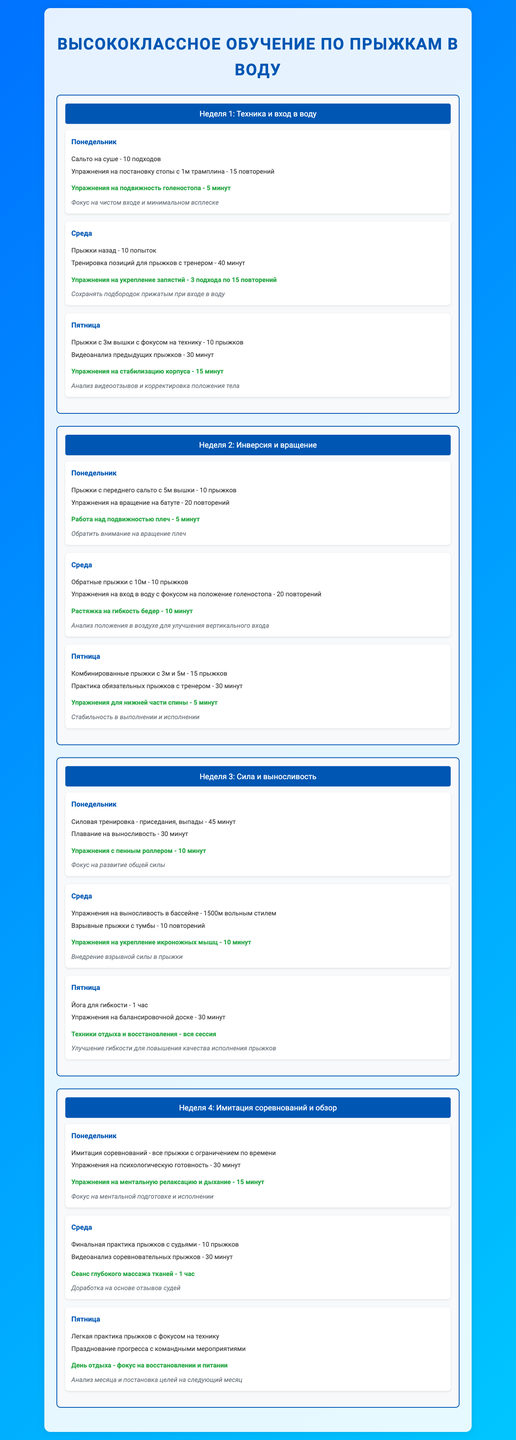what is the title of the document? The title is presented prominently at the top of the document.
Answer: Высококлассное обучение по прыжкам в воду how many weeks are covered in the training schedule? The document outlines a schedule that spans four weeks.
Answer: 4 how many jumps are planned for the last training day of the month? The document specifies the number of jumps for that day under the "Пятница" section at the end of the month.
Answer: 0 (легкая практика прыжков) what are the injury prevention exercises mentioned for Wednesday of Week 2? The specific exercises can be found listed under the "Упражнения на укрепление икроножных мышц" section for that day.
Answer: Упражнения на укрепление икроножных мышц what is the primary focus of the feedback for the first training day of Week 3? The feedback is given in the document specifically for that day, emphasizing general strength development.
Answer: Фокус на развитие общей силы how many minutes are allocated for video analysis on Friday of Week 1? This information is presented as part of the activities listed for that specific day.
Answer: 30 минут which day of the week is designated for combined jumps during Week 2? The specific activities for that week mention the day dedicated to combined jumps.
Answer: Пятница what type of training is scheduled for Monday of Week 4? The training type is explicitly stated in the activities planned for that day.
Answer: Имитация соревнований 